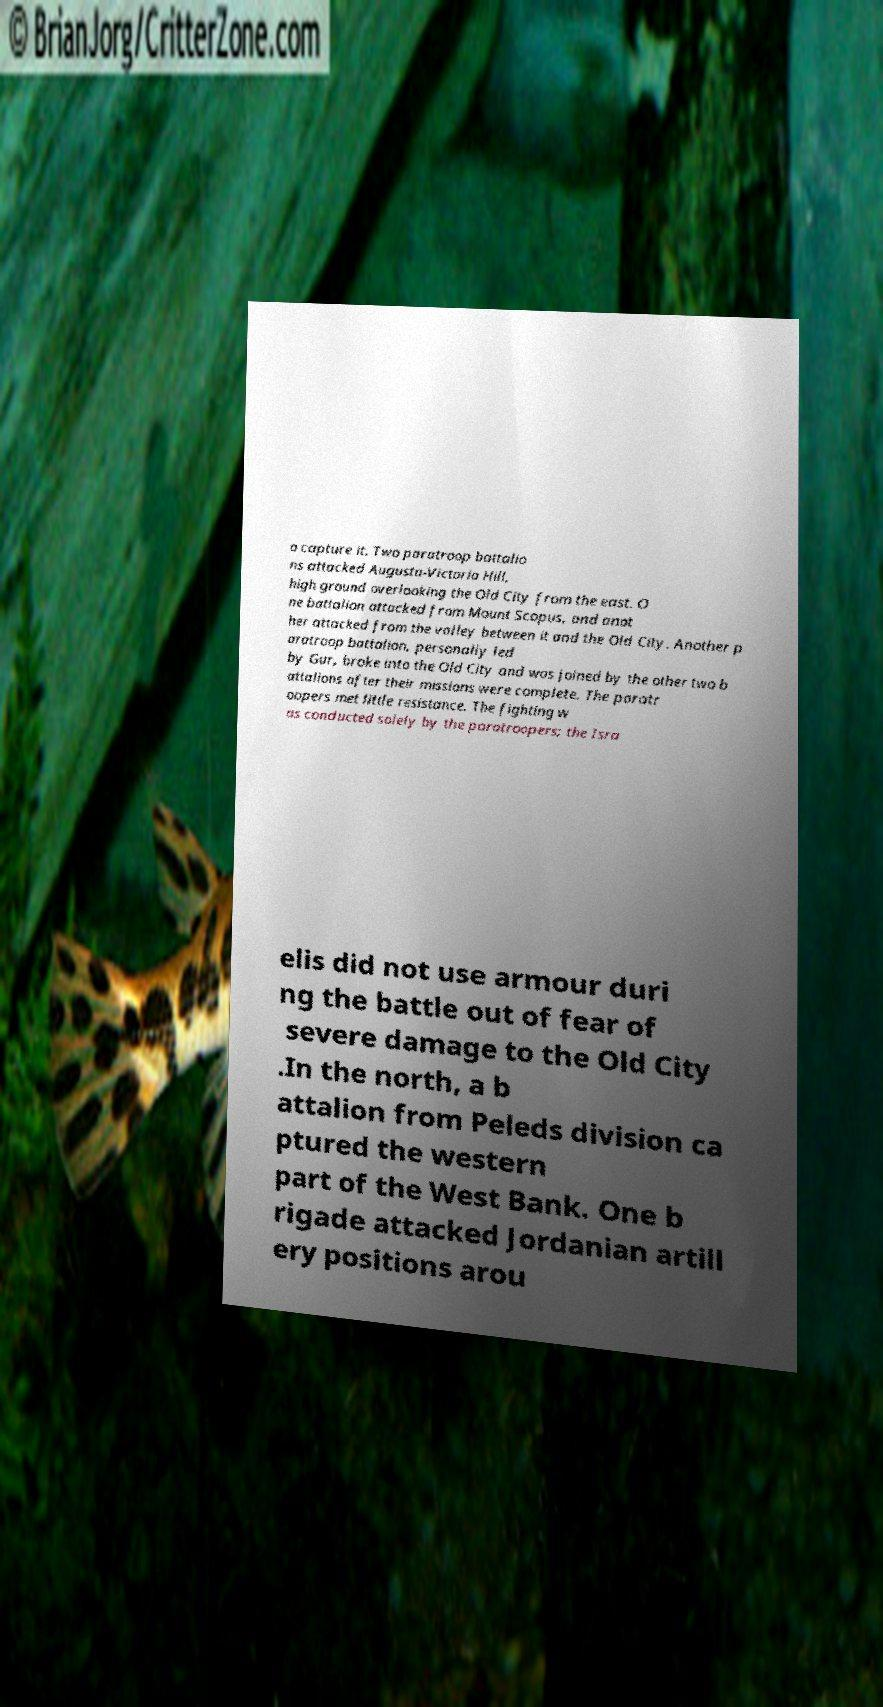What messages or text are displayed in this image? I need them in a readable, typed format. o capture it. Two paratroop battalio ns attacked Augusta-Victoria Hill, high ground overlooking the Old City from the east. O ne battalion attacked from Mount Scopus, and anot her attacked from the valley between it and the Old City. Another p aratroop battalion, personally led by Gur, broke into the Old City and was joined by the other two b attalions after their missions were complete. The paratr oopers met little resistance. The fighting w as conducted solely by the paratroopers; the Isra elis did not use armour duri ng the battle out of fear of severe damage to the Old City .In the north, a b attalion from Peleds division ca ptured the western part of the West Bank. One b rigade attacked Jordanian artill ery positions arou 